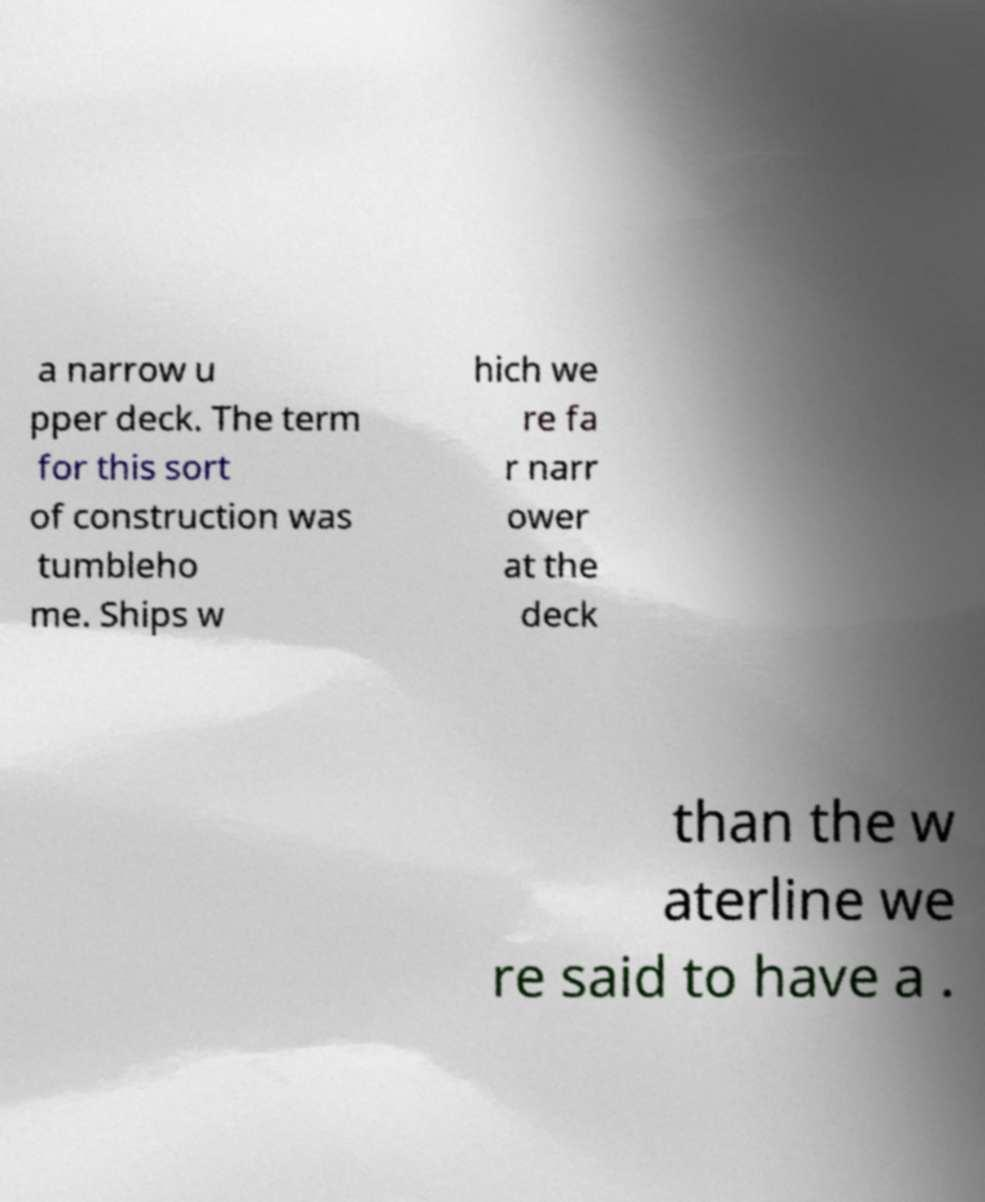There's text embedded in this image that I need extracted. Can you transcribe it verbatim? a narrow u pper deck. The term for this sort of construction was tumbleho me. Ships w hich we re fa r narr ower at the deck than the w aterline we re said to have a . 